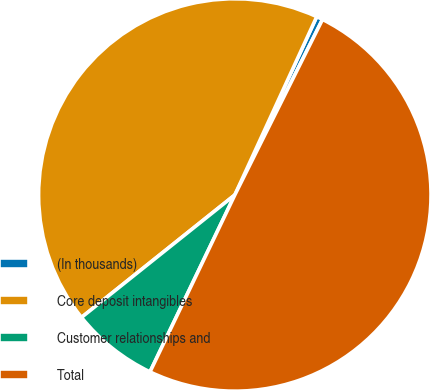<chart> <loc_0><loc_0><loc_500><loc_500><pie_chart><fcel>(In thousands)<fcel>Core deposit intangibles<fcel>Customer relationships and<fcel>Total<nl><fcel>0.52%<fcel>42.58%<fcel>7.16%<fcel>49.74%<nl></chart> 